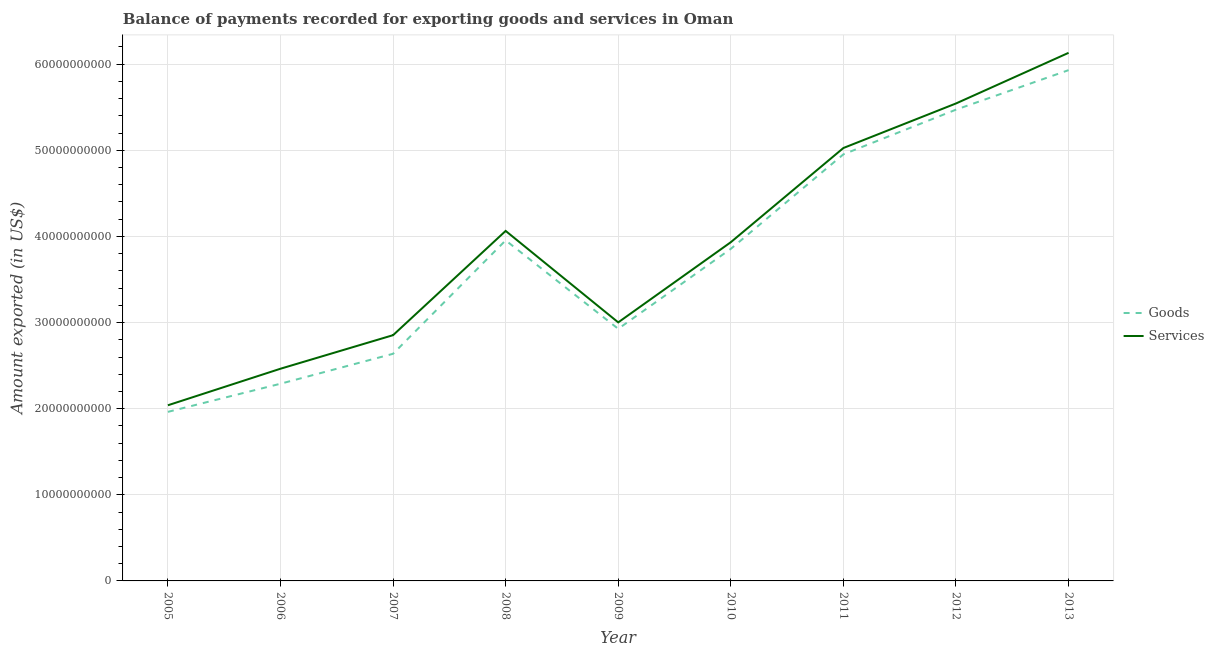How many different coloured lines are there?
Your response must be concise. 2. Does the line corresponding to amount of goods exported intersect with the line corresponding to amount of services exported?
Offer a very short reply. No. Is the number of lines equal to the number of legend labels?
Your answer should be very brief. Yes. What is the amount of goods exported in 2006?
Your answer should be very brief. 2.29e+1. Across all years, what is the maximum amount of goods exported?
Offer a terse response. 5.93e+1. Across all years, what is the minimum amount of goods exported?
Offer a terse response. 1.96e+1. What is the total amount of goods exported in the graph?
Your response must be concise. 3.40e+11. What is the difference between the amount of services exported in 2006 and that in 2008?
Provide a short and direct response. -1.60e+1. What is the difference between the amount of goods exported in 2010 and the amount of services exported in 2009?
Ensure brevity in your answer.  8.54e+09. What is the average amount of goods exported per year?
Ensure brevity in your answer.  3.78e+1. In the year 2010, what is the difference between the amount of services exported and amount of goods exported?
Give a very brief answer. 7.73e+08. What is the ratio of the amount of goods exported in 2012 to that in 2013?
Provide a short and direct response. 0.92. Is the amount of services exported in 2011 less than that in 2012?
Offer a very short reply. Yes. What is the difference between the highest and the second highest amount of services exported?
Your response must be concise. 5.88e+09. What is the difference between the highest and the lowest amount of services exported?
Keep it short and to the point. 4.09e+1. Is the amount of goods exported strictly greater than the amount of services exported over the years?
Ensure brevity in your answer.  No. Is the amount of goods exported strictly less than the amount of services exported over the years?
Offer a very short reply. Yes. What is the difference between two consecutive major ticks on the Y-axis?
Ensure brevity in your answer.  1.00e+1. Does the graph contain any zero values?
Provide a short and direct response. No. What is the title of the graph?
Provide a short and direct response. Balance of payments recorded for exporting goods and services in Oman. What is the label or title of the Y-axis?
Ensure brevity in your answer.  Amount exported (in US$). What is the Amount exported (in US$) in Goods in 2005?
Provide a short and direct response. 1.96e+1. What is the Amount exported (in US$) of Services in 2005?
Your answer should be compact. 2.04e+1. What is the Amount exported (in US$) of Goods in 2006?
Offer a terse response. 2.29e+1. What is the Amount exported (in US$) in Services in 2006?
Keep it short and to the point. 2.46e+1. What is the Amount exported (in US$) in Goods in 2007?
Offer a very short reply. 2.64e+1. What is the Amount exported (in US$) of Services in 2007?
Offer a terse response. 2.85e+1. What is the Amount exported (in US$) in Goods in 2008?
Offer a terse response. 3.95e+1. What is the Amount exported (in US$) of Services in 2008?
Your answer should be very brief. 4.06e+1. What is the Amount exported (in US$) of Goods in 2009?
Your answer should be very brief. 2.93e+1. What is the Amount exported (in US$) of Services in 2009?
Offer a terse response. 3.00e+1. What is the Amount exported (in US$) of Goods in 2010?
Give a very brief answer. 3.86e+1. What is the Amount exported (in US$) of Services in 2010?
Make the answer very short. 3.93e+1. What is the Amount exported (in US$) of Goods in 2011?
Your answer should be compact. 4.95e+1. What is the Amount exported (in US$) in Services in 2011?
Your answer should be very brief. 5.03e+1. What is the Amount exported (in US$) in Goods in 2012?
Your answer should be very brief. 5.47e+1. What is the Amount exported (in US$) of Services in 2012?
Offer a terse response. 5.54e+1. What is the Amount exported (in US$) of Goods in 2013?
Provide a short and direct response. 5.93e+1. What is the Amount exported (in US$) of Services in 2013?
Offer a very short reply. 6.13e+1. Across all years, what is the maximum Amount exported (in US$) of Goods?
Provide a short and direct response. 5.93e+1. Across all years, what is the maximum Amount exported (in US$) of Services?
Make the answer very short. 6.13e+1. Across all years, what is the minimum Amount exported (in US$) of Goods?
Keep it short and to the point. 1.96e+1. Across all years, what is the minimum Amount exported (in US$) of Services?
Ensure brevity in your answer.  2.04e+1. What is the total Amount exported (in US$) in Goods in the graph?
Make the answer very short. 3.40e+11. What is the total Amount exported (in US$) in Services in the graph?
Offer a very short reply. 3.51e+11. What is the difference between the Amount exported (in US$) in Goods in 2005 and that in 2006?
Give a very brief answer. -3.27e+09. What is the difference between the Amount exported (in US$) in Services in 2005 and that in 2006?
Ensure brevity in your answer.  -4.24e+09. What is the difference between the Amount exported (in US$) of Goods in 2005 and that in 2007?
Give a very brief answer. -6.74e+09. What is the difference between the Amount exported (in US$) of Services in 2005 and that in 2007?
Ensure brevity in your answer.  -8.14e+09. What is the difference between the Amount exported (in US$) in Goods in 2005 and that in 2008?
Offer a terse response. -1.99e+1. What is the difference between the Amount exported (in US$) of Services in 2005 and that in 2008?
Your response must be concise. -2.02e+1. What is the difference between the Amount exported (in US$) of Goods in 2005 and that in 2009?
Your response must be concise. -9.64e+09. What is the difference between the Amount exported (in US$) in Services in 2005 and that in 2009?
Make the answer very short. -9.63e+09. What is the difference between the Amount exported (in US$) in Goods in 2005 and that in 2010?
Provide a short and direct response. -1.89e+1. What is the difference between the Amount exported (in US$) of Services in 2005 and that in 2010?
Your answer should be very brief. -1.89e+1. What is the difference between the Amount exported (in US$) in Goods in 2005 and that in 2011?
Ensure brevity in your answer.  -2.99e+1. What is the difference between the Amount exported (in US$) of Services in 2005 and that in 2011?
Provide a short and direct response. -2.99e+1. What is the difference between the Amount exported (in US$) of Goods in 2005 and that in 2012?
Give a very brief answer. -3.51e+1. What is the difference between the Amount exported (in US$) in Services in 2005 and that in 2012?
Make the answer very short. -3.50e+1. What is the difference between the Amount exported (in US$) of Goods in 2005 and that in 2013?
Make the answer very short. -3.97e+1. What is the difference between the Amount exported (in US$) in Services in 2005 and that in 2013?
Your answer should be compact. -4.09e+1. What is the difference between the Amount exported (in US$) in Goods in 2006 and that in 2007?
Provide a short and direct response. -3.48e+09. What is the difference between the Amount exported (in US$) in Services in 2006 and that in 2007?
Make the answer very short. -3.90e+09. What is the difference between the Amount exported (in US$) of Goods in 2006 and that in 2008?
Offer a very short reply. -1.66e+1. What is the difference between the Amount exported (in US$) in Services in 2006 and that in 2008?
Your answer should be very brief. -1.60e+1. What is the difference between the Amount exported (in US$) in Goods in 2006 and that in 2009?
Your answer should be very brief. -6.37e+09. What is the difference between the Amount exported (in US$) of Services in 2006 and that in 2009?
Provide a short and direct response. -5.38e+09. What is the difference between the Amount exported (in US$) of Goods in 2006 and that in 2010?
Ensure brevity in your answer.  -1.57e+1. What is the difference between the Amount exported (in US$) of Services in 2006 and that in 2010?
Ensure brevity in your answer.  -1.47e+1. What is the difference between the Amount exported (in US$) in Goods in 2006 and that in 2011?
Offer a very short reply. -2.66e+1. What is the difference between the Amount exported (in US$) in Services in 2006 and that in 2011?
Make the answer very short. -2.56e+1. What is the difference between the Amount exported (in US$) of Goods in 2006 and that in 2012?
Your response must be concise. -3.18e+1. What is the difference between the Amount exported (in US$) of Services in 2006 and that in 2012?
Make the answer very short. -3.08e+1. What is the difference between the Amount exported (in US$) in Goods in 2006 and that in 2013?
Give a very brief answer. -3.64e+1. What is the difference between the Amount exported (in US$) of Services in 2006 and that in 2013?
Offer a terse response. -3.67e+1. What is the difference between the Amount exported (in US$) in Goods in 2007 and that in 2008?
Ensure brevity in your answer.  -1.32e+1. What is the difference between the Amount exported (in US$) of Services in 2007 and that in 2008?
Offer a terse response. -1.21e+1. What is the difference between the Amount exported (in US$) of Goods in 2007 and that in 2009?
Offer a very short reply. -2.90e+09. What is the difference between the Amount exported (in US$) in Services in 2007 and that in 2009?
Your answer should be compact. -1.49e+09. What is the difference between the Amount exported (in US$) in Goods in 2007 and that in 2010?
Give a very brief answer. -1.22e+1. What is the difference between the Amount exported (in US$) of Services in 2007 and that in 2010?
Ensure brevity in your answer.  -1.08e+1. What is the difference between the Amount exported (in US$) of Goods in 2007 and that in 2011?
Make the answer very short. -2.32e+1. What is the difference between the Amount exported (in US$) in Services in 2007 and that in 2011?
Make the answer very short. -2.17e+1. What is the difference between the Amount exported (in US$) of Goods in 2007 and that in 2012?
Offer a terse response. -2.83e+1. What is the difference between the Amount exported (in US$) of Services in 2007 and that in 2012?
Keep it short and to the point. -2.69e+1. What is the difference between the Amount exported (in US$) in Goods in 2007 and that in 2013?
Your answer should be compact. -3.29e+1. What is the difference between the Amount exported (in US$) of Services in 2007 and that in 2013?
Your response must be concise. -3.28e+1. What is the difference between the Amount exported (in US$) in Goods in 2008 and that in 2009?
Offer a very short reply. 1.03e+1. What is the difference between the Amount exported (in US$) in Services in 2008 and that in 2009?
Offer a terse response. 1.06e+1. What is the difference between the Amount exported (in US$) of Goods in 2008 and that in 2010?
Your answer should be very brief. 9.86e+08. What is the difference between the Amount exported (in US$) of Services in 2008 and that in 2010?
Ensure brevity in your answer.  1.31e+09. What is the difference between the Amount exported (in US$) of Goods in 2008 and that in 2011?
Make the answer very short. -9.99e+09. What is the difference between the Amount exported (in US$) in Services in 2008 and that in 2011?
Your answer should be compact. -9.63e+09. What is the difference between the Amount exported (in US$) in Goods in 2008 and that in 2012?
Your answer should be very brief. -1.52e+1. What is the difference between the Amount exported (in US$) of Services in 2008 and that in 2012?
Provide a succinct answer. -1.48e+1. What is the difference between the Amount exported (in US$) of Goods in 2008 and that in 2013?
Your answer should be compact. -1.98e+1. What is the difference between the Amount exported (in US$) of Services in 2008 and that in 2013?
Make the answer very short. -2.07e+1. What is the difference between the Amount exported (in US$) of Goods in 2009 and that in 2010?
Give a very brief answer. -9.29e+09. What is the difference between the Amount exported (in US$) of Services in 2009 and that in 2010?
Provide a short and direct response. -9.31e+09. What is the difference between the Amount exported (in US$) of Goods in 2009 and that in 2011?
Offer a terse response. -2.03e+1. What is the difference between the Amount exported (in US$) in Services in 2009 and that in 2011?
Provide a succinct answer. -2.02e+1. What is the difference between the Amount exported (in US$) of Goods in 2009 and that in 2012?
Keep it short and to the point. -2.55e+1. What is the difference between the Amount exported (in US$) in Services in 2009 and that in 2012?
Provide a succinct answer. -2.54e+1. What is the difference between the Amount exported (in US$) in Goods in 2009 and that in 2013?
Offer a terse response. -3.00e+1. What is the difference between the Amount exported (in US$) of Services in 2009 and that in 2013?
Keep it short and to the point. -3.13e+1. What is the difference between the Amount exported (in US$) in Goods in 2010 and that in 2011?
Give a very brief answer. -1.10e+1. What is the difference between the Amount exported (in US$) of Services in 2010 and that in 2011?
Provide a succinct answer. -1.09e+1. What is the difference between the Amount exported (in US$) of Goods in 2010 and that in 2012?
Provide a succinct answer. -1.62e+1. What is the difference between the Amount exported (in US$) of Services in 2010 and that in 2012?
Ensure brevity in your answer.  -1.61e+1. What is the difference between the Amount exported (in US$) of Goods in 2010 and that in 2013?
Your response must be concise. -2.08e+1. What is the difference between the Amount exported (in US$) in Services in 2010 and that in 2013?
Offer a very short reply. -2.20e+1. What is the difference between the Amount exported (in US$) in Goods in 2011 and that in 2012?
Give a very brief answer. -5.19e+09. What is the difference between the Amount exported (in US$) in Services in 2011 and that in 2012?
Offer a very short reply. -5.17e+09. What is the difference between the Amount exported (in US$) of Goods in 2011 and that in 2013?
Ensure brevity in your answer.  -9.78e+09. What is the difference between the Amount exported (in US$) of Services in 2011 and that in 2013?
Offer a terse response. -1.11e+1. What is the difference between the Amount exported (in US$) in Goods in 2012 and that in 2013?
Provide a succinct answer. -4.59e+09. What is the difference between the Amount exported (in US$) of Services in 2012 and that in 2013?
Offer a very short reply. -5.88e+09. What is the difference between the Amount exported (in US$) in Goods in 2005 and the Amount exported (in US$) in Services in 2006?
Provide a succinct answer. -5.01e+09. What is the difference between the Amount exported (in US$) of Goods in 2005 and the Amount exported (in US$) of Services in 2007?
Make the answer very short. -8.91e+09. What is the difference between the Amount exported (in US$) in Goods in 2005 and the Amount exported (in US$) in Services in 2008?
Your response must be concise. -2.10e+1. What is the difference between the Amount exported (in US$) of Goods in 2005 and the Amount exported (in US$) of Services in 2009?
Your response must be concise. -1.04e+1. What is the difference between the Amount exported (in US$) of Goods in 2005 and the Amount exported (in US$) of Services in 2010?
Ensure brevity in your answer.  -1.97e+1. What is the difference between the Amount exported (in US$) of Goods in 2005 and the Amount exported (in US$) of Services in 2011?
Your response must be concise. -3.06e+1. What is the difference between the Amount exported (in US$) of Goods in 2005 and the Amount exported (in US$) of Services in 2012?
Keep it short and to the point. -3.58e+1. What is the difference between the Amount exported (in US$) of Goods in 2005 and the Amount exported (in US$) of Services in 2013?
Your response must be concise. -4.17e+1. What is the difference between the Amount exported (in US$) in Goods in 2006 and the Amount exported (in US$) in Services in 2007?
Your answer should be very brief. -5.64e+09. What is the difference between the Amount exported (in US$) of Goods in 2006 and the Amount exported (in US$) of Services in 2008?
Offer a terse response. -1.77e+1. What is the difference between the Amount exported (in US$) of Goods in 2006 and the Amount exported (in US$) of Services in 2009?
Your answer should be compact. -7.12e+09. What is the difference between the Amount exported (in US$) of Goods in 2006 and the Amount exported (in US$) of Services in 2010?
Make the answer very short. -1.64e+1. What is the difference between the Amount exported (in US$) of Goods in 2006 and the Amount exported (in US$) of Services in 2011?
Your answer should be very brief. -2.74e+1. What is the difference between the Amount exported (in US$) in Goods in 2006 and the Amount exported (in US$) in Services in 2012?
Keep it short and to the point. -3.25e+1. What is the difference between the Amount exported (in US$) of Goods in 2006 and the Amount exported (in US$) of Services in 2013?
Your answer should be very brief. -3.84e+1. What is the difference between the Amount exported (in US$) of Goods in 2007 and the Amount exported (in US$) of Services in 2008?
Keep it short and to the point. -1.43e+1. What is the difference between the Amount exported (in US$) of Goods in 2007 and the Amount exported (in US$) of Services in 2009?
Provide a short and direct response. -3.65e+09. What is the difference between the Amount exported (in US$) of Goods in 2007 and the Amount exported (in US$) of Services in 2010?
Provide a succinct answer. -1.30e+1. What is the difference between the Amount exported (in US$) of Goods in 2007 and the Amount exported (in US$) of Services in 2011?
Offer a very short reply. -2.39e+1. What is the difference between the Amount exported (in US$) in Goods in 2007 and the Amount exported (in US$) in Services in 2012?
Provide a succinct answer. -2.91e+1. What is the difference between the Amount exported (in US$) in Goods in 2007 and the Amount exported (in US$) in Services in 2013?
Offer a very short reply. -3.49e+1. What is the difference between the Amount exported (in US$) of Goods in 2008 and the Amount exported (in US$) of Services in 2009?
Your answer should be compact. 9.52e+09. What is the difference between the Amount exported (in US$) of Goods in 2008 and the Amount exported (in US$) of Services in 2010?
Make the answer very short. 2.13e+08. What is the difference between the Amount exported (in US$) of Goods in 2008 and the Amount exported (in US$) of Services in 2011?
Provide a short and direct response. -1.07e+1. What is the difference between the Amount exported (in US$) of Goods in 2008 and the Amount exported (in US$) of Services in 2012?
Provide a succinct answer. -1.59e+1. What is the difference between the Amount exported (in US$) in Goods in 2008 and the Amount exported (in US$) in Services in 2013?
Give a very brief answer. -2.18e+1. What is the difference between the Amount exported (in US$) in Goods in 2009 and the Amount exported (in US$) in Services in 2010?
Your answer should be compact. -1.01e+1. What is the difference between the Amount exported (in US$) in Goods in 2009 and the Amount exported (in US$) in Services in 2011?
Give a very brief answer. -2.10e+1. What is the difference between the Amount exported (in US$) of Goods in 2009 and the Amount exported (in US$) of Services in 2012?
Give a very brief answer. -2.62e+1. What is the difference between the Amount exported (in US$) in Goods in 2009 and the Amount exported (in US$) in Services in 2013?
Your answer should be compact. -3.20e+1. What is the difference between the Amount exported (in US$) of Goods in 2010 and the Amount exported (in US$) of Services in 2011?
Your answer should be very brief. -1.17e+1. What is the difference between the Amount exported (in US$) in Goods in 2010 and the Amount exported (in US$) in Services in 2012?
Your answer should be very brief. -1.69e+1. What is the difference between the Amount exported (in US$) in Goods in 2010 and the Amount exported (in US$) in Services in 2013?
Make the answer very short. -2.28e+1. What is the difference between the Amount exported (in US$) in Goods in 2011 and the Amount exported (in US$) in Services in 2012?
Ensure brevity in your answer.  -5.91e+09. What is the difference between the Amount exported (in US$) of Goods in 2011 and the Amount exported (in US$) of Services in 2013?
Keep it short and to the point. -1.18e+1. What is the difference between the Amount exported (in US$) of Goods in 2012 and the Amount exported (in US$) of Services in 2013?
Offer a terse response. -6.60e+09. What is the average Amount exported (in US$) of Goods per year?
Give a very brief answer. 3.78e+1. What is the average Amount exported (in US$) of Services per year?
Give a very brief answer. 3.90e+1. In the year 2005, what is the difference between the Amount exported (in US$) of Goods and Amount exported (in US$) of Services?
Ensure brevity in your answer.  -7.65e+08. In the year 2006, what is the difference between the Amount exported (in US$) of Goods and Amount exported (in US$) of Services?
Keep it short and to the point. -1.74e+09. In the year 2007, what is the difference between the Amount exported (in US$) of Goods and Amount exported (in US$) of Services?
Give a very brief answer. -2.16e+09. In the year 2008, what is the difference between the Amount exported (in US$) in Goods and Amount exported (in US$) in Services?
Offer a terse response. -1.10e+09. In the year 2009, what is the difference between the Amount exported (in US$) in Goods and Amount exported (in US$) in Services?
Your response must be concise. -7.49e+08. In the year 2010, what is the difference between the Amount exported (in US$) of Goods and Amount exported (in US$) of Services?
Your answer should be very brief. -7.73e+08. In the year 2011, what is the difference between the Amount exported (in US$) in Goods and Amount exported (in US$) in Services?
Offer a very short reply. -7.34e+08. In the year 2012, what is the difference between the Amount exported (in US$) of Goods and Amount exported (in US$) of Services?
Your answer should be compact. -7.18e+08. In the year 2013, what is the difference between the Amount exported (in US$) of Goods and Amount exported (in US$) of Services?
Provide a succinct answer. -2.01e+09. What is the ratio of the Amount exported (in US$) of Goods in 2005 to that in 2006?
Provide a short and direct response. 0.86. What is the ratio of the Amount exported (in US$) of Services in 2005 to that in 2006?
Offer a terse response. 0.83. What is the ratio of the Amount exported (in US$) of Goods in 2005 to that in 2007?
Make the answer very short. 0.74. What is the ratio of the Amount exported (in US$) in Services in 2005 to that in 2007?
Your response must be concise. 0.71. What is the ratio of the Amount exported (in US$) in Goods in 2005 to that in 2008?
Offer a terse response. 0.5. What is the ratio of the Amount exported (in US$) of Services in 2005 to that in 2008?
Offer a very short reply. 0.5. What is the ratio of the Amount exported (in US$) of Goods in 2005 to that in 2009?
Your answer should be compact. 0.67. What is the ratio of the Amount exported (in US$) in Services in 2005 to that in 2009?
Provide a short and direct response. 0.68. What is the ratio of the Amount exported (in US$) in Goods in 2005 to that in 2010?
Provide a succinct answer. 0.51. What is the ratio of the Amount exported (in US$) in Services in 2005 to that in 2010?
Your answer should be very brief. 0.52. What is the ratio of the Amount exported (in US$) in Goods in 2005 to that in 2011?
Provide a short and direct response. 0.4. What is the ratio of the Amount exported (in US$) in Services in 2005 to that in 2011?
Provide a succinct answer. 0.41. What is the ratio of the Amount exported (in US$) in Goods in 2005 to that in 2012?
Make the answer very short. 0.36. What is the ratio of the Amount exported (in US$) in Services in 2005 to that in 2012?
Ensure brevity in your answer.  0.37. What is the ratio of the Amount exported (in US$) of Goods in 2005 to that in 2013?
Your answer should be compact. 0.33. What is the ratio of the Amount exported (in US$) in Services in 2005 to that in 2013?
Provide a succinct answer. 0.33. What is the ratio of the Amount exported (in US$) in Goods in 2006 to that in 2007?
Provide a short and direct response. 0.87. What is the ratio of the Amount exported (in US$) in Services in 2006 to that in 2007?
Give a very brief answer. 0.86. What is the ratio of the Amount exported (in US$) in Goods in 2006 to that in 2008?
Offer a very short reply. 0.58. What is the ratio of the Amount exported (in US$) in Services in 2006 to that in 2008?
Make the answer very short. 0.61. What is the ratio of the Amount exported (in US$) of Goods in 2006 to that in 2009?
Provide a short and direct response. 0.78. What is the ratio of the Amount exported (in US$) in Services in 2006 to that in 2009?
Keep it short and to the point. 0.82. What is the ratio of the Amount exported (in US$) in Goods in 2006 to that in 2010?
Ensure brevity in your answer.  0.59. What is the ratio of the Amount exported (in US$) of Services in 2006 to that in 2010?
Offer a terse response. 0.63. What is the ratio of the Amount exported (in US$) in Goods in 2006 to that in 2011?
Keep it short and to the point. 0.46. What is the ratio of the Amount exported (in US$) of Services in 2006 to that in 2011?
Provide a short and direct response. 0.49. What is the ratio of the Amount exported (in US$) of Goods in 2006 to that in 2012?
Ensure brevity in your answer.  0.42. What is the ratio of the Amount exported (in US$) in Services in 2006 to that in 2012?
Make the answer very short. 0.44. What is the ratio of the Amount exported (in US$) of Goods in 2006 to that in 2013?
Your response must be concise. 0.39. What is the ratio of the Amount exported (in US$) of Services in 2006 to that in 2013?
Ensure brevity in your answer.  0.4. What is the ratio of the Amount exported (in US$) of Goods in 2007 to that in 2008?
Offer a terse response. 0.67. What is the ratio of the Amount exported (in US$) in Services in 2007 to that in 2008?
Offer a terse response. 0.7. What is the ratio of the Amount exported (in US$) in Goods in 2007 to that in 2009?
Offer a very short reply. 0.9. What is the ratio of the Amount exported (in US$) in Services in 2007 to that in 2009?
Make the answer very short. 0.95. What is the ratio of the Amount exported (in US$) of Goods in 2007 to that in 2010?
Offer a very short reply. 0.68. What is the ratio of the Amount exported (in US$) in Services in 2007 to that in 2010?
Give a very brief answer. 0.73. What is the ratio of the Amount exported (in US$) in Goods in 2007 to that in 2011?
Your answer should be very brief. 0.53. What is the ratio of the Amount exported (in US$) in Services in 2007 to that in 2011?
Give a very brief answer. 0.57. What is the ratio of the Amount exported (in US$) of Goods in 2007 to that in 2012?
Your answer should be very brief. 0.48. What is the ratio of the Amount exported (in US$) in Services in 2007 to that in 2012?
Your response must be concise. 0.51. What is the ratio of the Amount exported (in US$) of Goods in 2007 to that in 2013?
Give a very brief answer. 0.44. What is the ratio of the Amount exported (in US$) in Services in 2007 to that in 2013?
Your answer should be compact. 0.47. What is the ratio of the Amount exported (in US$) of Goods in 2008 to that in 2009?
Keep it short and to the point. 1.35. What is the ratio of the Amount exported (in US$) of Services in 2008 to that in 2009?
Your answer should be compact. 1.35. What is the ratio of the Amount exported (in US$) in Goods in 2008 to that in 2010?
Offer a terse response. 1.03. What is the ratio of the Amount exported (in US$) of Goods in 2008 to that in 2011?
Make the answer very short. 0.8. What is the ratio of the Amount exported (in US$) of Services in 2008 to that in 2011?
Offer a very short reply. 0.81. What is the ratio of the Amount exported (in US$) in Goods in 2008 to that in 2012?
Provide a succinct answer. 0.72. What is the ratio of the Amount exported (in US$) in Services in 2008 to that in 2012?
Give a very brief answer. 0.73. What is the ratio of the Amount exported (in US$) in Goods in 2008 to that in 2013?
Your response must be concise. 0.67. What is the ratio of the Amount exported (in US$) of Services in 2008 to that in 2013?
Your response must be concise. 0.66. What is the ratio of the Amount exported (in US$) of Goods in 2009 to that in 2010?
Your response must be concise. 0.76. What is the ratio of the Amount exported (in US$) in Services in 2009 to that in 2010?
Keep it short and to the point. 0.76. What is the ratio of the Amount exported (in US$) of Goods in 2009 to that in 2011?
Your answer should be compact. 0.59. What is the ratio of the Amount exported (in US$) of Services in 2009 to that in 2011?
Give a very brief answer. 0.6. What is the ratio of the Amount exported (in US$) of Goods in 2009 to that in 2012?
Your answer should be compact. 0.53. What is the ratio of the Amount exported (in US$) of Services in 2009 to that in 2012?
Provide a succinct answer. 0.54. What is the ratio of the Amount exported (in US$) of Goods in 2009 to that in 2013?
Provide a short and direct response. 0.49. What is the ratio of the Amount exported (in US$) in Services in 2009 to that in 2013?
Make the answer very short. 0.49. What is the ratio of the Amount exported (in US$) of Goods in 2010 to that in 2011?
Offer a very short reply. 0.78. What is the ratio of the Amount exported (in US$) in Services in 2010 to that in 2011?
Provide a short and direct response. 0.78. What is the ratio of the Amount exported (in US$) in Goods in 2010 to that in 2012?
Keep it short and to the point. 0.7. What is the ratio of the Amount exported (in US$) of Services in 2010 to that in 2012?
Give a very brief answer. 0.71. What is the ratio of the Amount exported (in US$) in Goods in 2010 to that in 2013?
Provide a short and direct response. 0.65. What is the ratio of the Amount exported (in US$) in Services in 2010 to that in 2013?
Ensure brevity in your answer.  0.64. What is the ratio of the Amount exported (in US$) of Goods in 2011 to that in 2012?
Your response must be concise. 0.91. What is the ratio of the Amount exported (in US$) of Services in 2011 to that in 2012?
Make the answer very short. 0.91. What is the ratio of the Amount exported (in US$) of Goods in 2011 to that in 2013?
Provide a succinct answer. 0.84. What is the ratio of the Amount exported (in US$) of Services in 2011 to that in 2013?
Your answer should be compact. 0.82. What is the ratio of the Amount exported (in US$) of Goods in 2012 to that in 2013?
Provide a short and direct response. 0.92. What is the ratio of the Amount exported (in US$) of Services in 2012 to that in 2013?
Keep it short and to the point. 0.9. What is the difference between the highest and the second highest Amount exported (in US$) of Goods?
Offer a very short reply. 4.59e+09. What is the difference between the highest and the second highest Amount exported (in US$) of Services?
Your response must be concise. 5.88e+09. What is the difference between the highest and the lowest Amount exported (in US$) in Goods?
Provide a succinct answer. 3.97e+1. What is the difference between the highest and the lowest Amount exported (in US$) in Services?
Your answer should be very brief. 4.09e+1. 